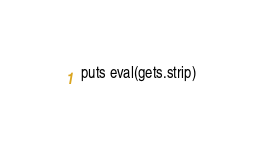<code> <loc_0><loc_0><loc_500><loc_500><_Ruby_>puts eval(gets.strip)</code> 